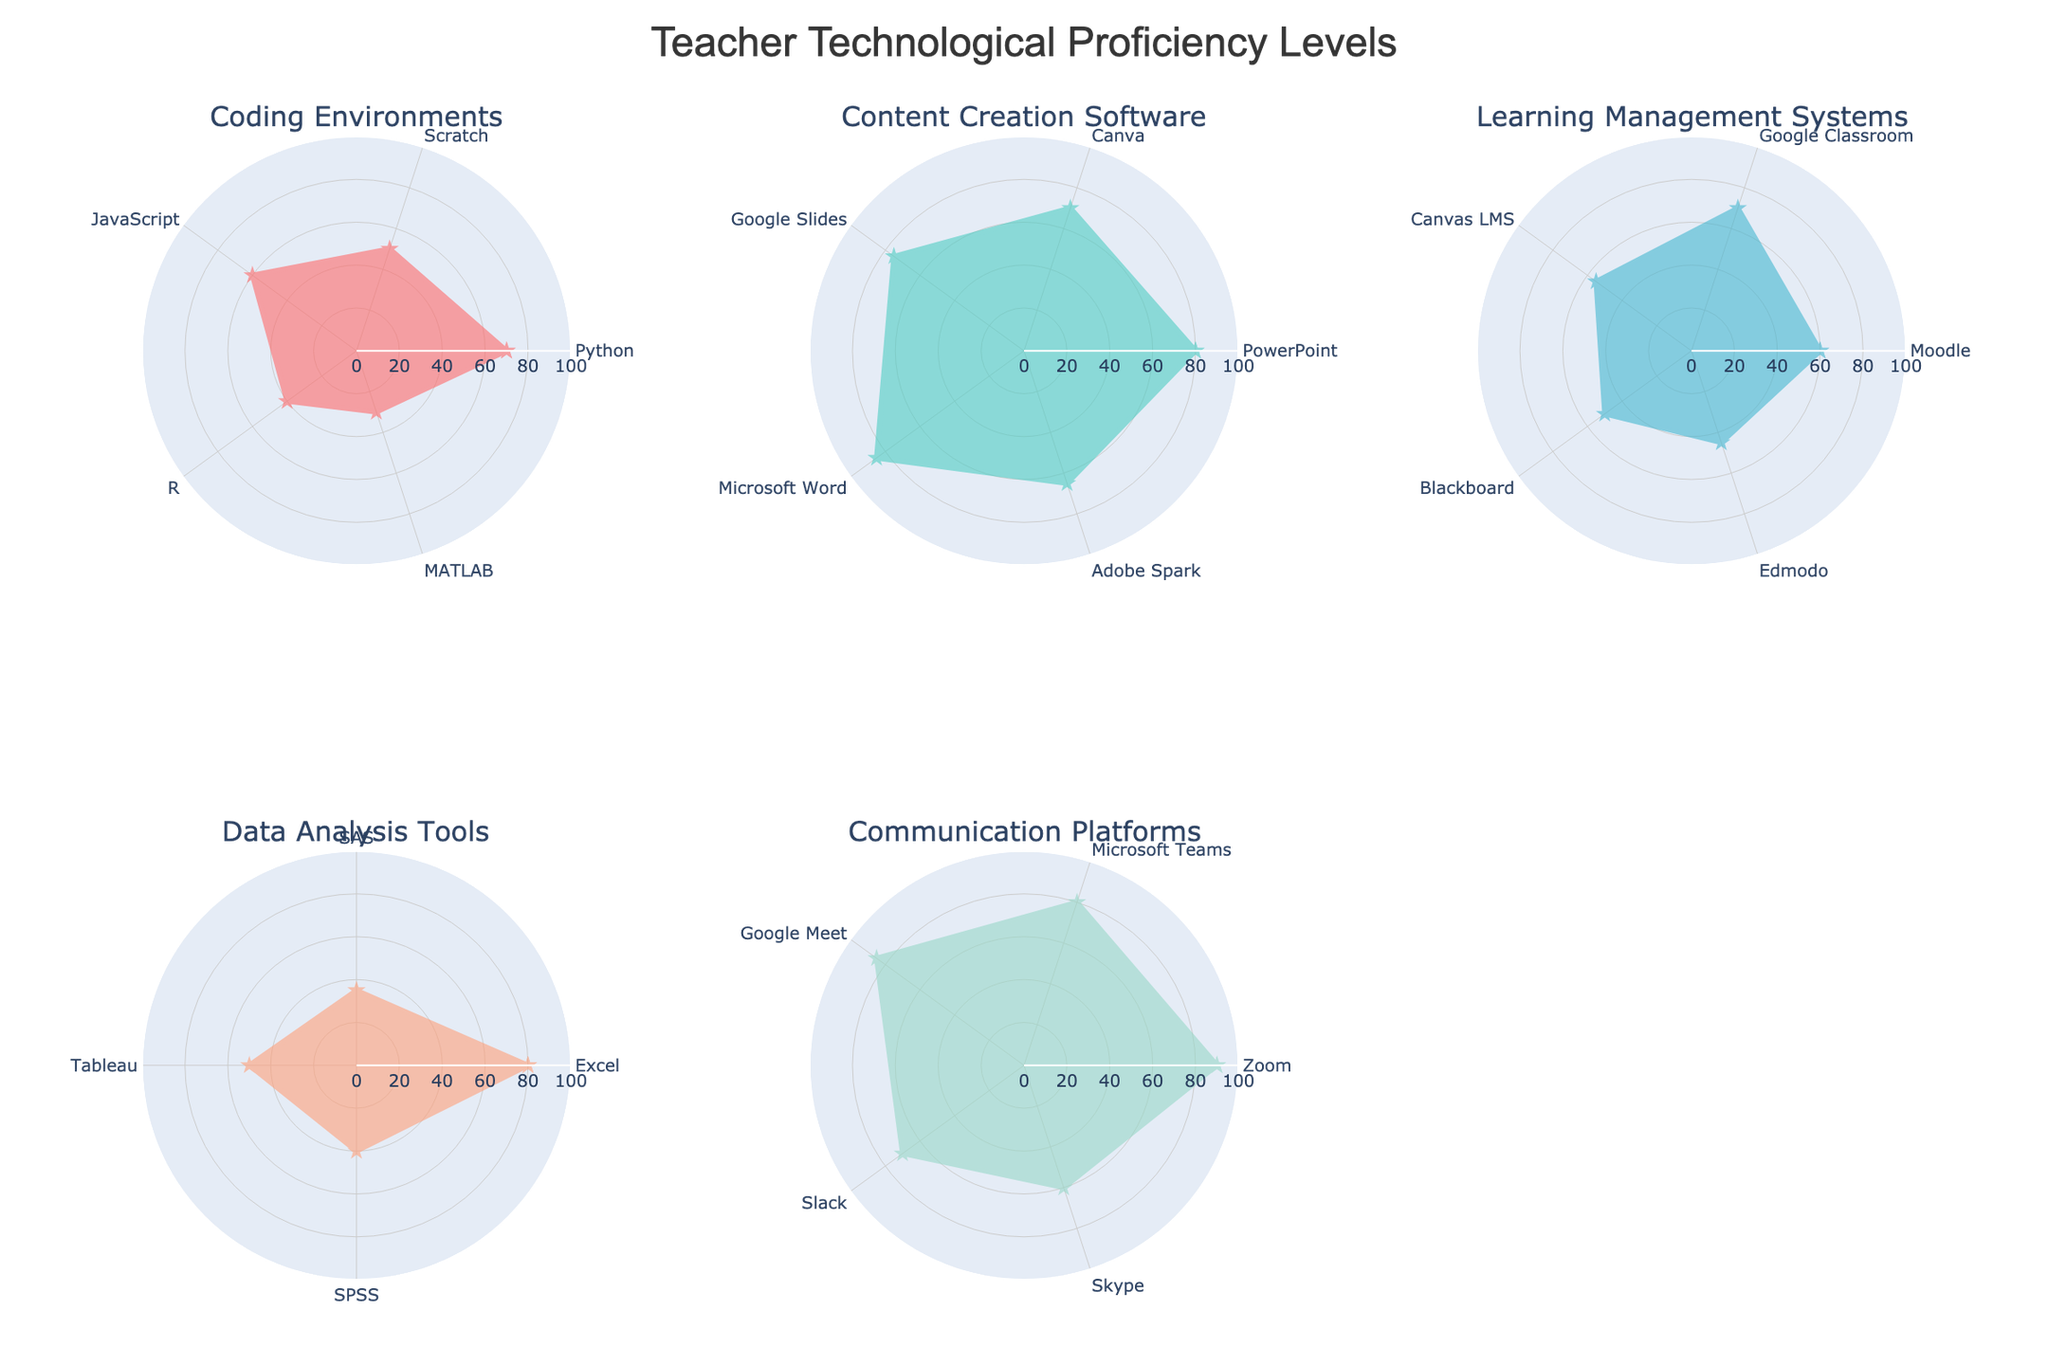What is the title of the radar chart? The title of the chart is usually displayed prominently at the top of the figure. It gives an overall context of the data being visualized.
Answer: Teacher Technological Proficiency Levels What are the categories of tools represented in the radar chart? By examining the titles of the subplots, you can identify the main categories of tools.
Answer: Coding Environments, Content Creation Software, Learning Management Systems, Data Analysis Tools, Communication Platforms Which tool has the highest proficiency level in the Content Creation Software category? Look at the Content Creation Software subplot and identify the tool with the highest value on the radial axis.
Answer: Microsoft Word Compare the proficiency levels of Python and JavaScript. Which one is higher? Locate the points for Python and JavaScript on the Coding Environments subplot and compare their values on the radial axis.
Answer: Python How many tools are in the Communication Platforms category? Count the number of tools represented in the Communication Platforms subplot.
Answer: 5 What is the average proficiency level for the tools in the Learning Management Systems category? Add up the proficiency levels for Moodle (60), Google Classroom (70), Canvas LMS (55), Blackboard (50), and Edmodo (45). Then, divide by the number of tools (5). (60 + 70 + 55 + 50 + 45) / 5 = 56
Answer: 56 Which category has the least variance in proficiency levels? Calculate or estimate the range of proficiency levels for each category to see which one has the smallest range or spread.
Answer: Communication Platforms Are there any categories where all tools have a proficiency level above 50? Examine each category to see if all the tools within it have proficiency levels that are above 50.
Answer: Communication Platforms Which tool has the lowest proficiency in the Data Analysis Tools category? Locate the point with the smallest value on the radial axis in the Data Analysis Tools subplot.
Answer: SAS How do the proficiency levels of tools in Content Creation Software compare to those in Coding Environments? Look at the values on the radial axes for both subplots and compare the levels of tools between the two categories.
Answer: Higher in Content Creation Software 